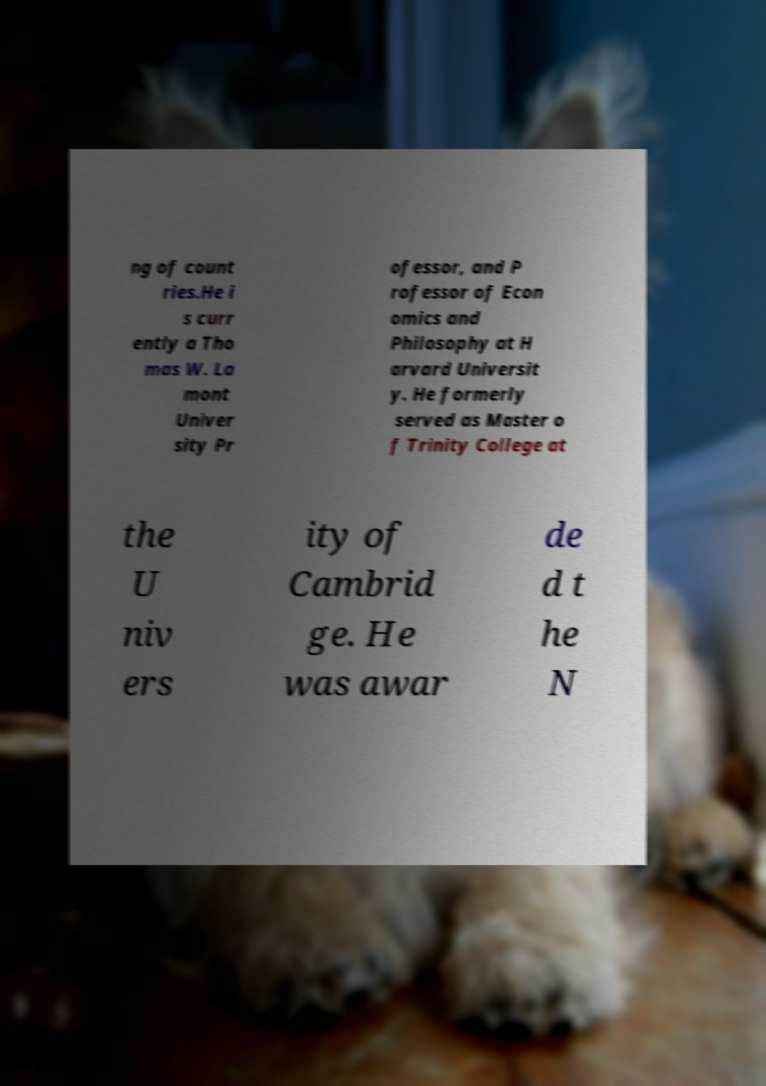What messages or text are displayed in this image? I need them in a readable, typed format. ng of count ries.He i s curr ently a Tho mas W. La mont Univer sity Pr ofessor, and P rofessor of Econ omics and Philosophy at H arvard Universit y. He formerly served as Master o f Trinity College at the U niv ers ity of Cambrid ge. He was awar de d t he N 